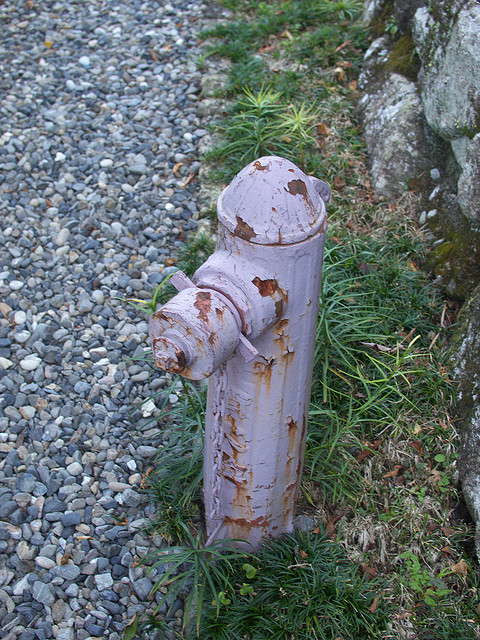Are there any other objects around it? Yes, there are other objects around the fireplug. It is surrounded by small gray pebbles and some greenery, including patches of grass and a few weeds. Part of a rock or a wall is also visible on the right side of the image. 